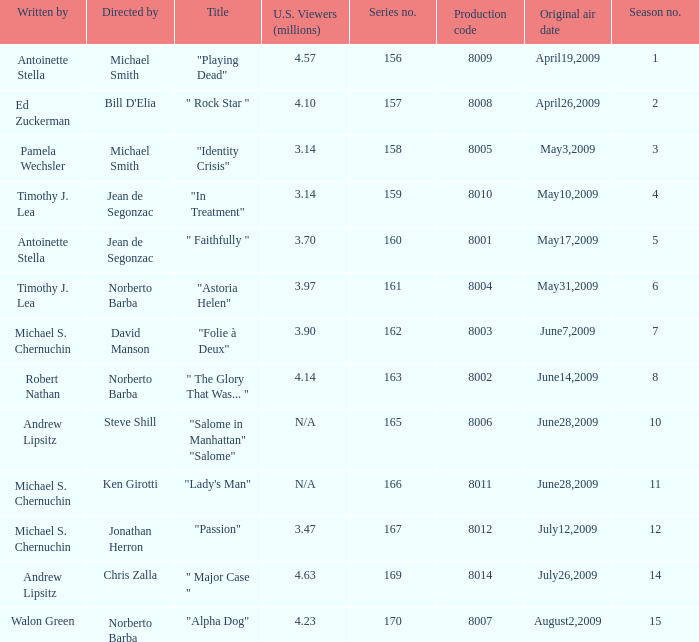Who are the writer of the series episode number 170? Walon Green. 